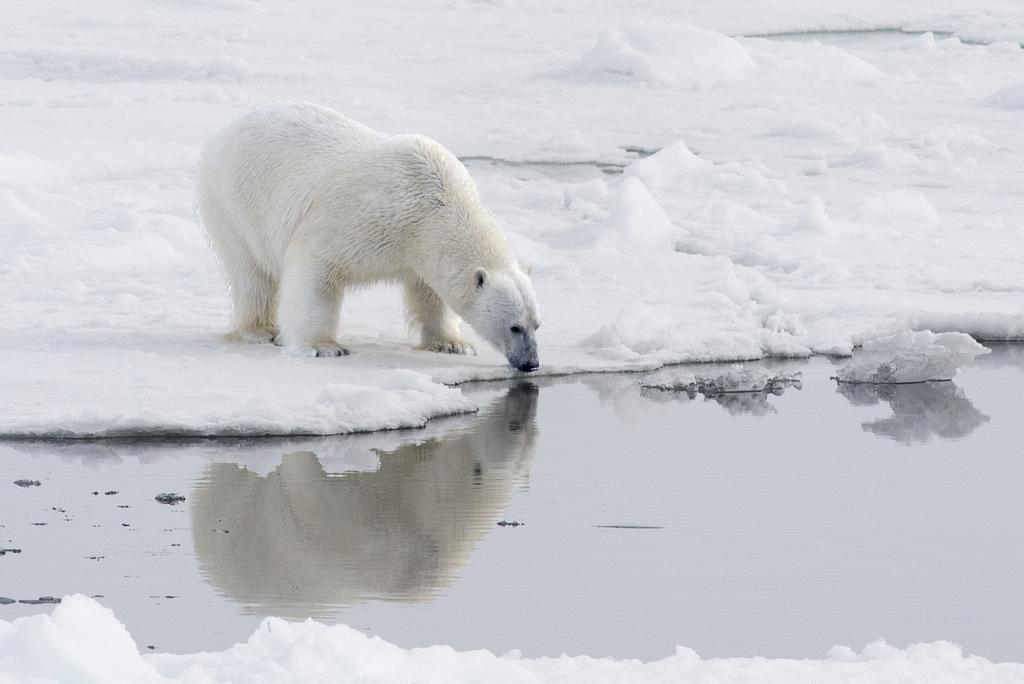What is the condition of the ground in the image? The ground in the image is covered in snow. What animal can be seen standing on the snow? There is a white-colored polar bear standing on the snow. What is visible at the bottom of the image? Water is visible at the bottom of the image. Can you tell me how many ants are crawling on the polar bear in the image? There are no ants present in the image; the only animal visible is the polar bear. 